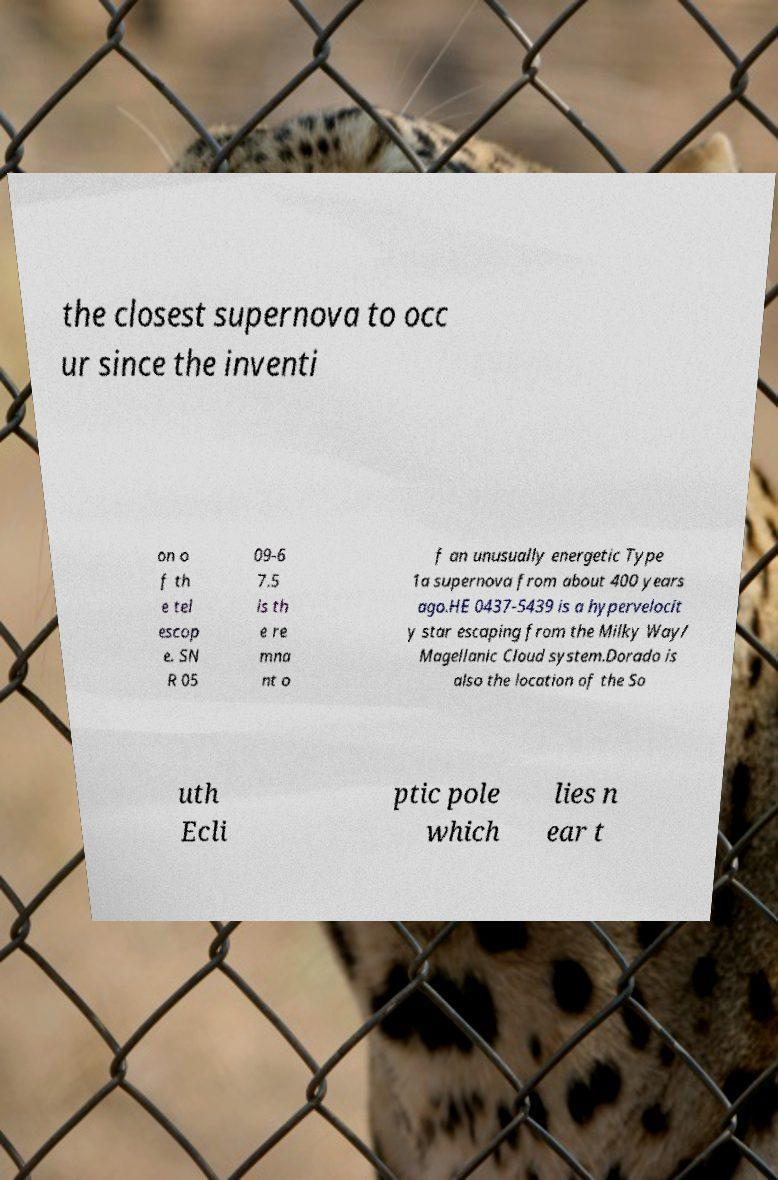Please identify and transcribe the text found in this image. the closest supernova to occ ur since the inventi on o f th e tel escop e. SN R 05 09-6 7.5 is th e re mna nt o f an unusually energetic Type 1a supernova from about 400 years ago.HE 0437-5439 is a hypervelocit y star escaping from the Milky Way/ Magellanic Cloud system.Dorado is also the location of the So uth Ecli ptic pole which lies n ear t 